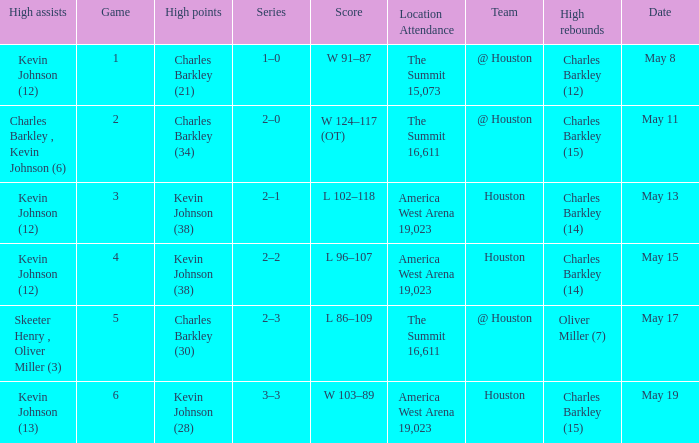Who did the high points in game number 1? Charles Barkley (21). 